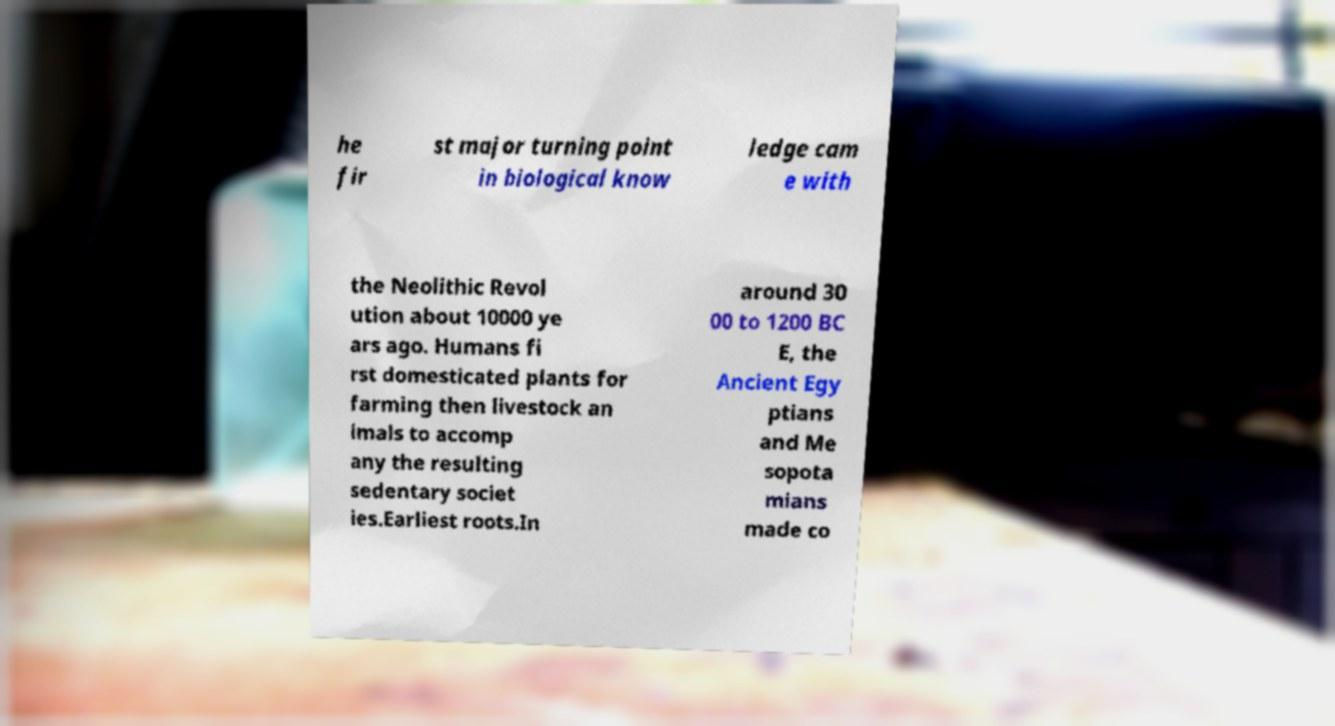There's text embedded in this image that I need extracted. Can you transcribe it verbatim? he fir st major turning point in biological know ledge cam e with the Neolithic Revol ution about 10000 ye ars ago. Humans fi rst domesticated plants for farming then livestock an imals to accomp any the resulting sedentary societ ies.Earliest roots.In around 30 00 to 1200 BC E, the Ancient Egy ptians and Me sopota mians made co 